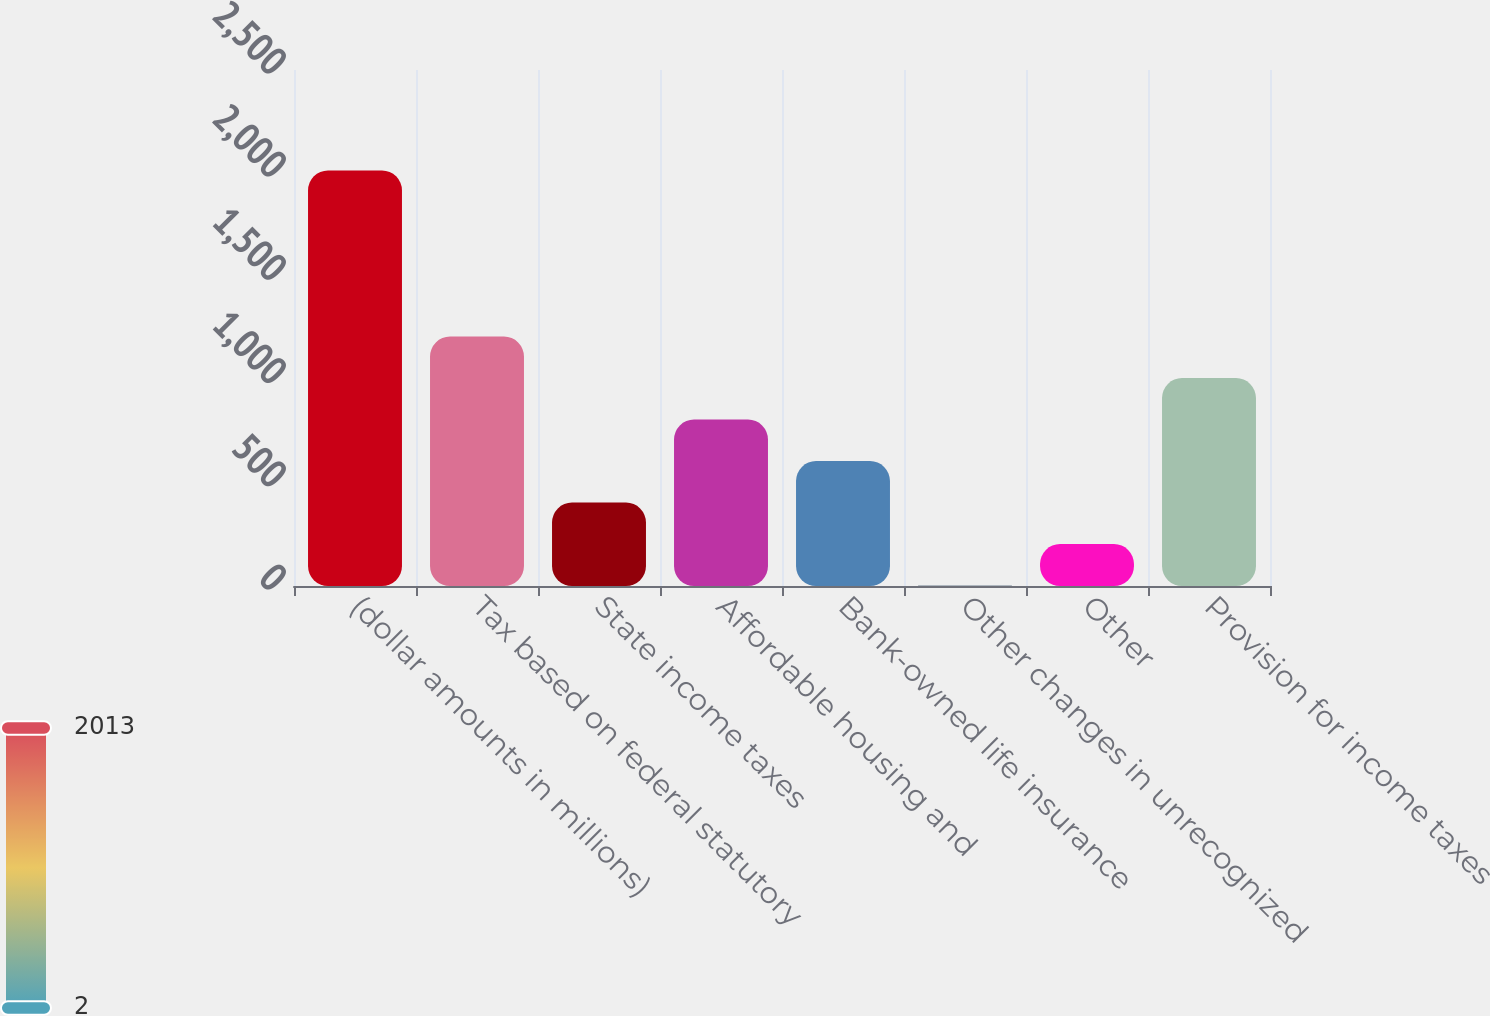Convert chart. <chart><loc_0><loc_0><loc_500><loc_500><bar_chart><fcel>(dollar amounts in millions)<fcel>Tax based on federal statutory<fcel>State income taxes<fcel>Affordable housing and<fcel>Bank-owned life insurance<fcel>Other changes in unrecognized<fcel>Other<fcel>Provision for income taxes<nl><fcel>2013<fcel>1208.6<fcel>404.2<fcel>806.4<fcel>605.3<fcel>2<fcel>203.1<fcel>1007.5<nl></chart> 